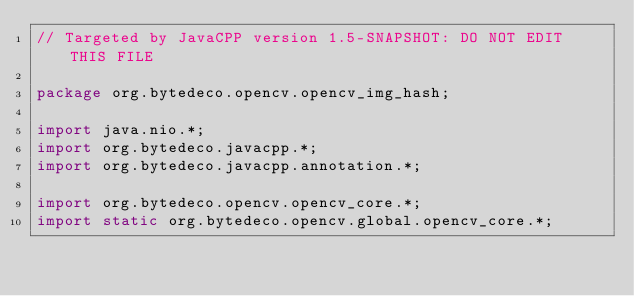Convert code to text. <code><loc_0><loc_0><loc_500><loc_500><_Java_>// Targeted by JavaCPP version 1.5-SNAPSHOT: DO NOT EDIT THIS FILE

package org.bytedeco.opencv.opencv_img_hash;

import java.nio.*;
import org.bytedeco.javacpp.*;
import org.bytedeco.javacpp.annotation.*;

import org.bytedeco.opencv.opencv_core.*;
import static org.bytedeco.opencv.global.opencv_core.*;</code> 